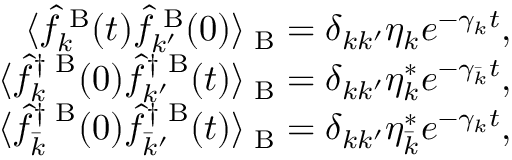<formula> <loc_0><loc_0><loc_500><loc_500>\begin{array} { r } { \langle \hat { f } _ { k } ^ { B } ( t ) \hat { f } _ { k ^ { \prime } } ^ { B } ( 0 ) \rangle _ { B } = \delta _ { k k ^ { \prime } } \eta _ { k } e ^ { - \gamma _ { k } t } , } \\ { \langle \hat { f } _ { k } ^ { \dag B } ( 0 ) \hat { f } _ { k ^ { \prime } } ^ { \dag B } ( t ) \rangle _ { B } = \delta _ { k k ^ { \prime } } \eta _ { k } ^ { * } e ^ { - \gamma _ { \bar { k } } t } , } \\ { \langle \hat { f } _ { \bar { k } } ^ { \dag B } ( 0 ) \hat { f } _ { \bar { k } ^ { \prime } } ^ { \dag B } ( t ) \rangle _ { B } = \delta _ { k k ^ { \prime } } \eta _ { \bar { k } } ^ { * } e ^ { - \gamma _ { k } t } , } \end{array}</formula> 